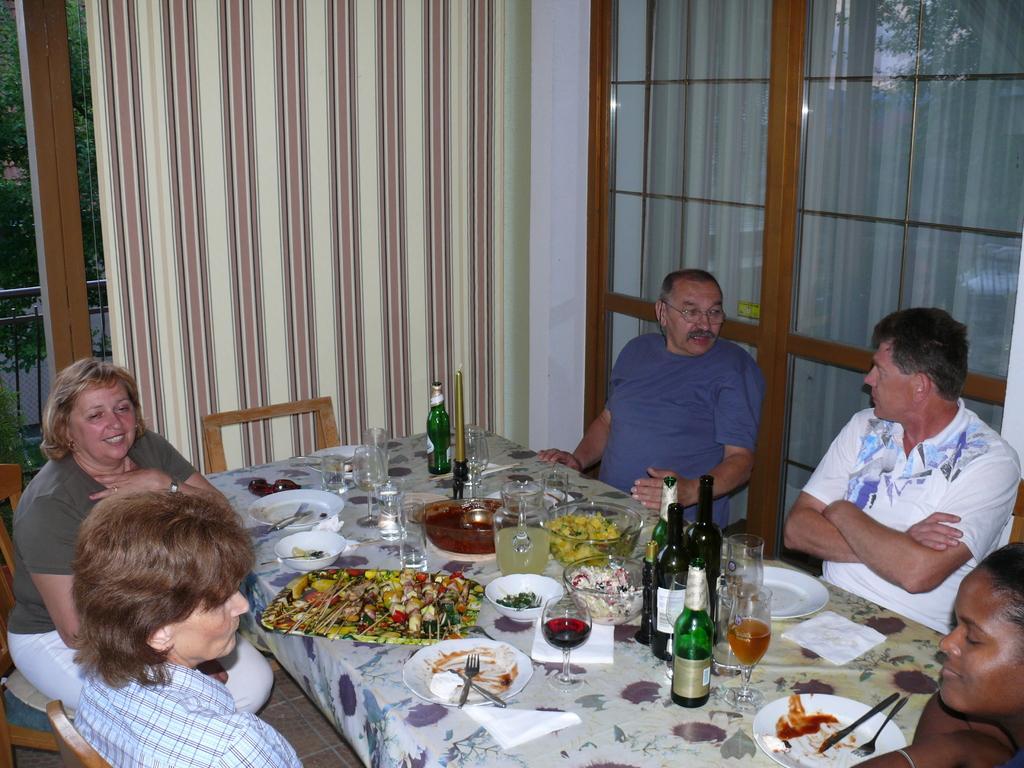In one or two sentences, can you explain what this image depicts? Here we can see five persons are sitting on the chairs. This is table. On the table there are plates, bowls, bottles, and glasses. On the background there is a glass and this is curtain. Here we can see some trees. 